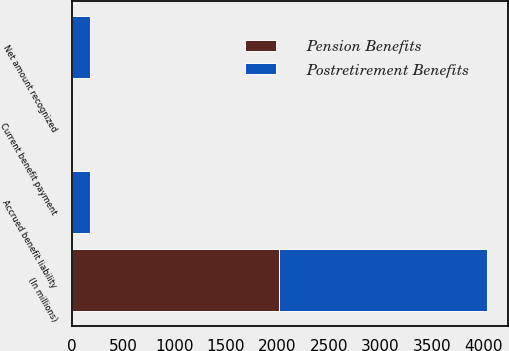Convert chart to OTSL. <chart><loc_0><loc_0><loc_500><loc_500><stacked_bar_chart><ecel><fcel>(In millions)<fcel>Current benefit payment<fcel>Accrued benefit liability<fcel>Net amount recognized<nl><fcel>Postretirement Benefits<fcel>2017<fcel>1.1<fcel>174.7<fcel>175.8<nl><fcel>Pension Benefits<fcel>2017<fcel>0.2<fcel>1.4<fcel>1.6<nl></chart> 